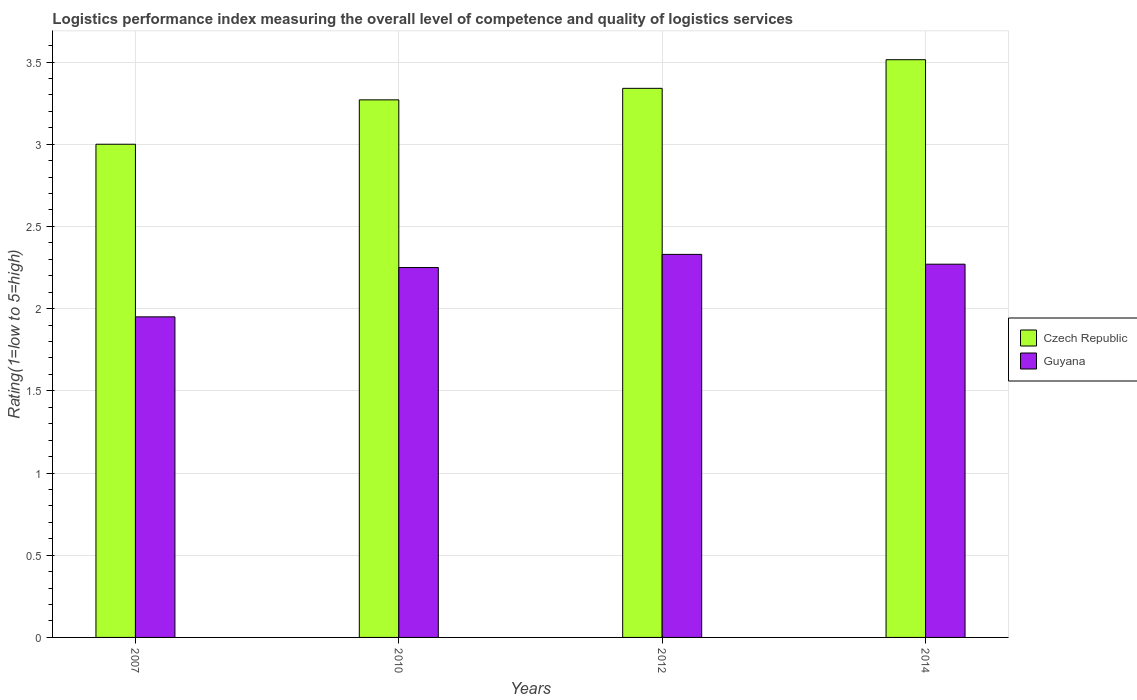Are the number of bars on each tick of the X-axis equal?
Give a very brief answer. Yes. How many bars are there on the 4th tick from the left?
Your answer should be compact. 2. How many bars are there on the 3rd tick from the right?
Your response must be concise. 2. What is the label of the 3rd group of bars from the left?
Keep it short and to the point. 2012. What is the Logistic performance index in Czech Republic in 2012?
Provide a short and direct response. 3.34. Across all years, what is the maximum Logistic performance index in Guyana?
Give a very brief answer. 2.33. Across all years, what is the minimum Logistic performance index in Guyana?
Provide a succinct answer. 1.95. In which year was the Logistic performance index in Guyana maximum?
Provide a short and direct response. 2012. What is the total Logistic performance index in Guyana in the graph?
Offer a terse response. 8.8. What is the difference between the Logistic performance index in Czech Republic in 2012 and that in 2014?
Keep it short and to the point. -0.17. What is the difference between the Logistic performance index in Guyana in 2010 and the Logistic performance index in Czech Republic in 2012?
Ensure brevity in your answer.  -1.09. What is the average Logistic performance index in Guyana per year?
Your answer should be very brief. 2.2. In the year 2007, what is the difference between the Logistic performance index in Czech Republic and Logistic performance index in Guyana?
Your answer should be very brief. 1.05. In how many years, is the Logistic performance index in Guyana greater than 0.7?
Provide a short and direct response. 4. What is the ratio of the Logistic performance index in Czech Republic in 2010 to that in 2014?
Ensure brevity in your answer.  0.93. Is the Logistic performance index in Czech Republic in 2012 less than that in 2014?
Ensure brevity in your answer.  Yes. What is the difference between the highest and the second highest Logistic performance index in Guyana?
Provide a short and direct response. 0.06. What is the difference between the highest and the lowest Logistic performance index in Guyana?
Your response must be concise. 0.38. In how many years, is the Logistic performance index in Czech Republic greater than the average Logistic performance index in Czech Republic taken over all years?
Provide a succinct answer. 2. Is the sum of the Logistic performance index in Guyana in 2010 and 2012 greater than the maximum Logistic performance index in Czech Republic across all years?
Your answer should be compact. Yes. What does the 2nd bar from the left in 2012 represents?
Ensure brevity in your answer.  Guyana. What does the 1st bar from the right in 2010 represents?
Give a very brief answer. Guyana. How many years are there in the graph?
Ensure brevity in your answer.  4. Does the graph contain any zero values?
Your response must be concise. No. Does the graph contain grids?
Ensure brevity in your answer.  Yes. Where does the legend appear in the graph?
Your response must be concise. Center right. What is the title of the graph?
Your answer should be compact. Logistics performance index measuring the overall level of competence and quality of logistics services. What is the label or title of the Y-axis?
Make the answer very short. Rating(1=low to 5=high). What is the Rating(1=low to 5=high) of Czech Republic in 2007?
Provide a succinct answer. 3. What is the Rating(1=low to 5=high) in Guyana in 2007?
Your answer should be compact. 1.95. What is the Rating(1=low to 5=high) of Czech Republic in 2010?
Keep it short and to the point. 3.27. What is the Rating(1=low to 5=high) in Guyana in 2010?
Offer a terse response. 2.25. What is the Rating(1=low to 5=high) of Czech Republic in 2012?
Keep it short and to the point. 3.34. What is the Rating(1=low to 5=high) of Guyana in 2012?
Make the answer very short. 2.33. What is the Rating(1=low to 5=high) of Czech Republic in 2014?
Ensure brevity in your answer.  3.51. What is the Rating(1=low to 5=high) in Guyana in 2014?
Your answer should be very brief. 2.27. Across all years, what is the maximum Rating(1=low to 5=high) in Czech Republic?
Make the answer very short. 3.51. Across all years, what is the maximum Rating(1=low to 5=high) of Guyana?
Offer a terse response. 2.33. Across all years, what is the minimum Rating(1=low to 5=high) in Guyana?
Keep it short and to the point. 1.95. What is the total Rating(1=low to 5=high) of Czech Republic in the graph?
Your answer should be very brief. 13.12. What is the total Rating(1=low to 5=high) in Guyana in the graph?
Your answer should be compact. 8.8. What is the difference between the Rating(1=low to 5=high) in Czech Republic in 2007 and that in 2010?
Offer a very short reply. -0.27. What is the difference between the Rating(1=low to 5=high) in Czech Republic in 2007 and that in 2012?
Your answer should be compact. -0.34. What is the difference between the Rating(1=low to 5=high) of Guyana in 2007 and that in 2012?
Give a very brief answer. -0.38. What is the difference between the Rating(1=low to 5=high) in Czech Republic in 2007 and that in 2014?
Provide a succinct answer. -0.51. What is the difference between the Rating(1=low to 5=high) of Guyana in 2007 and that in 2014?
Keep it short and to the point. -0.32. What is the difference between the Rating(1=low to 5=high) in Czech Republic in 2010 and that in 2012?
Make the answer very short. -0.07. What is the difference between the Rating(1=low to 5=high) of Guyana in 2010 and that in 2012?
Offer a very short reply. -0.08. What is the difference between the Rating(1=low to 5=high) in Czech Republic in 2010 and that in 2014?
Your answer should be very brief. -0.24. What is the difference between the Rating(1=low to 5=high) of Guyana in 2010 and that in 2014?
Provide a short and direct response. -0.02. What is the difference between the Rating(1=low to 5=high) in Czech Republic in 2012 and that in 2014?
Offer a terse response. -0.17. What is the difference between the Rating(1=low to 5=high) in Guyana in 2012 and that in 2014?
Your answer should be compact. 0.06. What is the difference between the Rating(1=low to 5=high) in Czech Republic in 2007 and the Rating(1=low to 5=high) in Guyana in 2012?
Ensure brevity in your answer.  0.67. What is the difference between the Rating(1=low to 5=high) of Czech Republic in 2007 and the Rating(1=low to 5=high) of Guyana in 2014?
Ensure brevity in your answer.  0.73. What is the difference between the Rating(1=low to 5=high) in Czech Republic in 2010 and the Rating(1=low to 5=high) in Guyana in 2012?
Offer a very short reply. 0.94. What is the difference between the Rating(1=low to 5=high) in Czech Republic in 2012 and the Rating(1=low to 5=high) in Guyana in 2014?
Provide a succinct answer. 1.07. What is the average Rating(1=low to 5=high) of Czech Republic per year?
Make the answer very short. 3.28. What is the average Rating(1=low to 5=high) of Guyana per year?
Offer a very short reply. 2.2. In the year 2007, what is the difference between the Rating(1=low to 5=high) in Czech Republic and Rating(1=low to 5=high) in Guyana?
Provide a short and direct response. 1.05. In the year 2010, what is the difference between the Rating(1=low to 5=high) of Czech Republic and Rating(1=low to 5=high) of Guyana?
Your response must be concise. 1.02. In the year 2014, what is the difference between the Rating(1=low to 5=high) of Czech Republic and Rating(1=low to 5=high) of Guyana?
Make the answer very short. 1.24. What is the ratio of the Rating(1=low to 5=high) of Czech Republic in 2007 to that in 2010?
Make the answer very short. 0.92. What is the ratio of the Rating(1=low to 5=high) in Guyana in 2007 to that in 2010?
Offer a terse response. 0.87. What is the ratio of the Rating(1=low to 5=high) of Czech Republic in 2007 to that in 2012?
Ensure brevity in your answer.  0.9. What is the ratio of the Rating(1=low to 5=high) in Guyana in 2007 to that in 2012?
Provide a short and direct response. 0.84. What is the ratio of the Rating(1=low to 5=high) of Czech Republic in 2007 to that in 2014?
Provide a short and direct response. 0.85. What is the ratio of the Rating(1=low to 5=high) of Guyana in 2007 to that in 2014?
Your answer should be compact. 0.86. What is the ratio of the Rating(1=low to 5=high) in Czech Republic in 2010 to that in 2012?
Give a very brief answer. 0.98. What is the ratio of the Rating(1=low to 5=high) of Guyana in 2010 to that in 2012?
Offer a very short reply. 0.97. What is the ratio of the Rating(1=low to 5=high) in Czech Republic in 2010 to that in 2014?
Offer a terse response. 0.93. What is the ratio of the Rating(1=low to 5=high) of Czech Republic in 2012 to that in 2014?
Give a very brief answer. 0.95. What is the ratio of the Rating(1=low to 5=high) in Guyana in 2012 to that in 2014?
Keep it short and to the point. 1.03. What is the difference between the highest and the second highest Rating(1=low to 5=high) in Czech Republic?
Your answer should be very brief. 0.17. What is the difference between the highest and the second highest Rating(1=low to 5=high) of Guyana?
Give a very brief answer. 0.06. What is the difference between the highest and the lowest Rating(1=low to 5=high) in Czech Republic?
Your answer should be compact. 0.51. What is the difference between the highest and the lowest Rating(1=low to 5=high) in Guyana?
Ensure brevity in your answer.  0.38. 